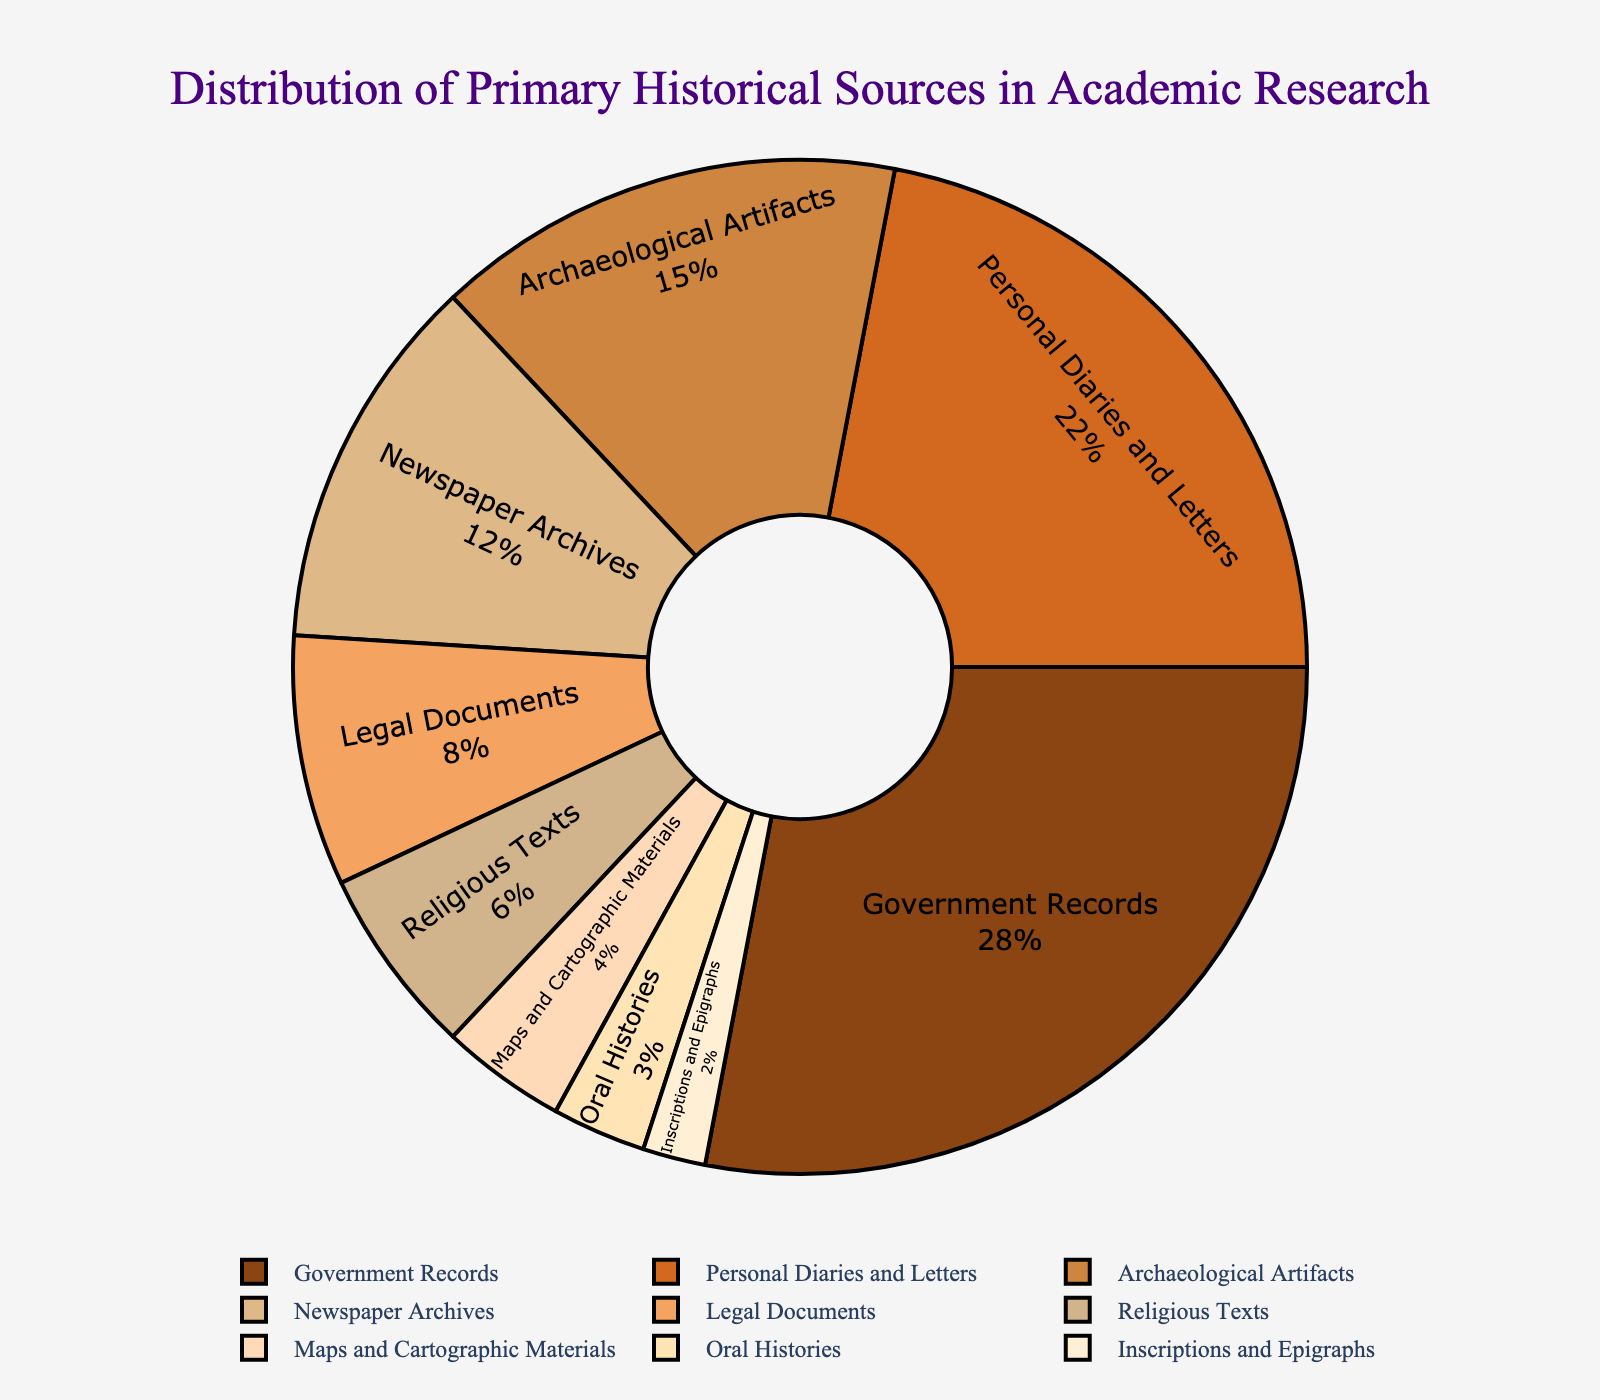What percentage of primary historical sources used in academic research are Government Records? By looking at the pie chart, we can find the sector labeled "Government Records". The percentage label shows 28%.
Answer: 28% Which category has a higher percentage of use: Personal Diaries and Letters or Archaeological Artifacts? First, identify the sectors labeled "Personal Diaries and Letters" and "Archaeological Artifacts" on the pie chart. The percentage for Personal Diaries and Letters is 22%, and for Archaeological Artifacts, it is 15%. Since 22% is greater than 15%, Personal Diaries and Letters have a higher percentage of use.
Answer: Personal Diaries and Letters What is the total percentage of the categories that individually contribute less than 10% each? The categories contributing less than 10% are Legal Documents (8%), Religious Texts (6%), Maps and Cartographic Materials (4%), Oral Histories (3%), and Inscriptions and Epigraphs (2%). Summing these values: 8 + 6 + 4 + 3 + 2 = 23%.
Answer: 23% By how much does the percentage of Government Records exceed the percentage of Newspaper Archives? First, identify the percentages: Government Records (28%) and Newspaper Archives (12%). Subtract the percentage of Newspaper Archives from Government Records: 28% - 12% = 16%.
Answer: 16% What is the combined percentage of Personal Diaries and Letters and Newspaper Archives? Identify the percentages: Personal Diaries and Letters (22%) and Newspaper Archives (12%). Add these values together: 22% + 12% = 34%.
Answer: 34% Which category has the smallest percentage? The pie chart shows each category with its percentage. The category labeled "Inscriptions and Epigraphs" has the smallest percentage, which is 2%.
Answer: Inscriptions and Epigraphs Which category is represented by the darkest brown color, and what is its percentage? The darkest brown color corresponds to the category "Government Records". The pie chart indicates that Government Records have a percentage of 28%.
Answer: Government Records, 28% How many categories contribute more than 20% each to the total distribution? Identify the sectors that have a percentage greater than 20. The categories "Government Records" (28%) and "Personal Diaries and Letters" (22%) each exceed 20%. There are 2 such categories.
Answer: 2 What percentage of the total distribution is represented by Newspaper Archives relative to all other categories combined? First, Newspaper Archives is 12%. Subtract this from 100 to get the combined percentage of all other categories: 100% - 12% = 88%.
Answer: 88% 